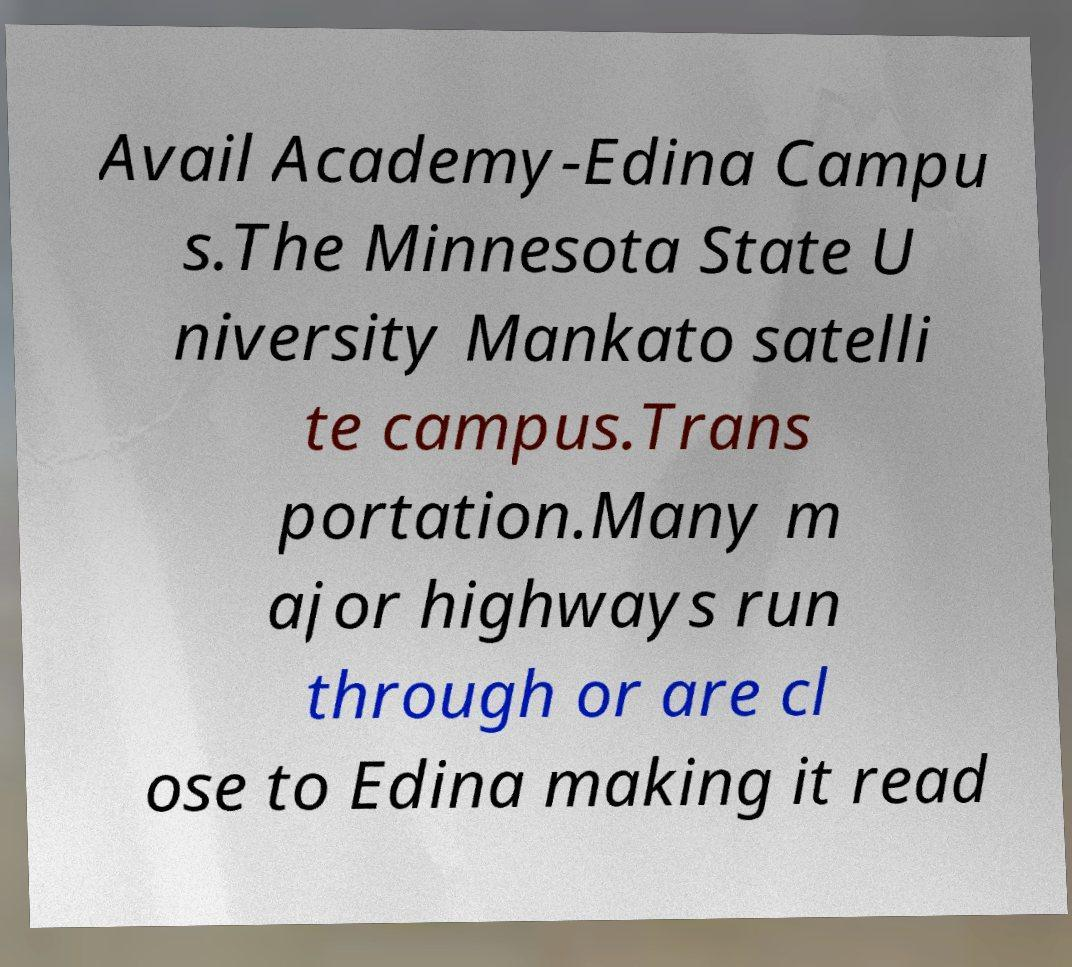There's text embedded in this image that I need extracted. Can you transcribe it verbatim? Avail Academy-Edina Campu s.The Minnesota State U niversity Mankato satelli te campus.Trans portation.Many m ajor highways run through or are cl ose to Edina making it read 